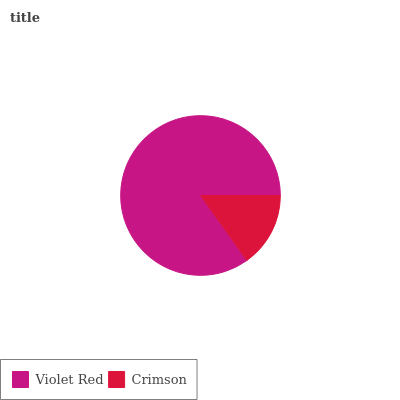Is Crimson the minimum?
Answer yes or no. Yes. Is Violet Red the maximum?
Answer yes or no. Yes. Is Crimson the maximum?
Answer yes or no. No. Is Violet Red greater than Crimson?
Answer yes or no. Yes. Is Crimson less than Violet Red?
Answer yes or no. Yes. Is Crimson greater than Violet Red?
Answer yes or no. No. Is Violet Red less than Crimson?
Answer yes or no. No. Is Violet Red the high median?
Answer yes or no. Yes. Is Crimson the low median?
Answer yes or no. Yes. Is Crimson the high median?
Answer yes or no. No. Is Violet Red the low median?
Answer yes or no. No. 